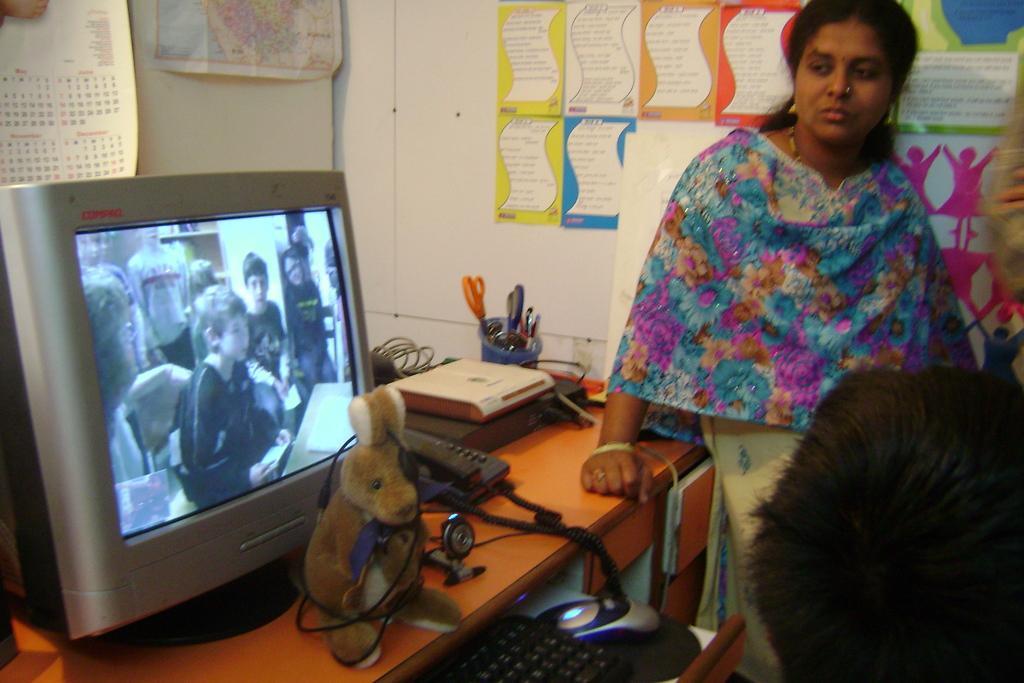Can you describe this image briefly? As we can see in the image there is a white color wall, calendar, paper a woman standing over here and a table. On table there is a mouse, keyboard, screen, toy, telephone and pens. 